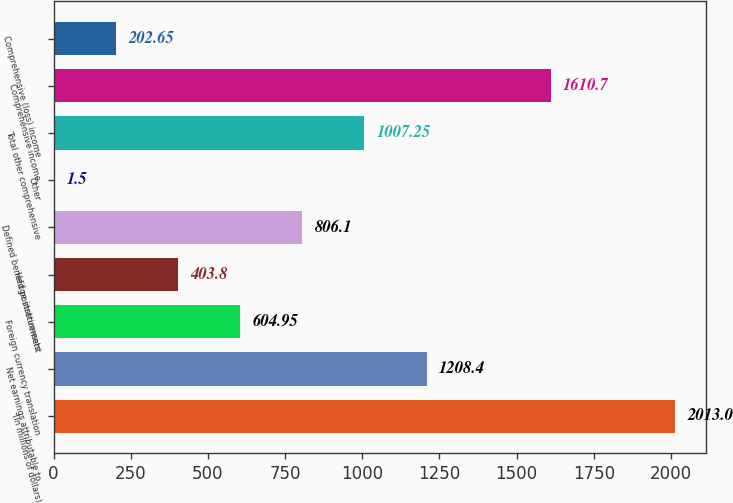Convert chart. <chart><loc_0><loc_0><loc_500><loc_500><bar_chart><fcel>(in millions of dollars)<fcel>Net earnings attributable to<fcel>Foreign currency translation<fcel>Hedge instruments<fcel>Defined benefit postretirement<fcel>Other<fcel>Total other comprehensive<fcel>Comprehensive income<fcel>Comprehensive (loss) income<nl><fcel>2013<fcel>1208.4<fcel>604.95<fcel>403.8<fcel>806.1<fcel>1.5<fcel>1007.25<fcel>1610.7<fcel>202.65<nl></chart> 